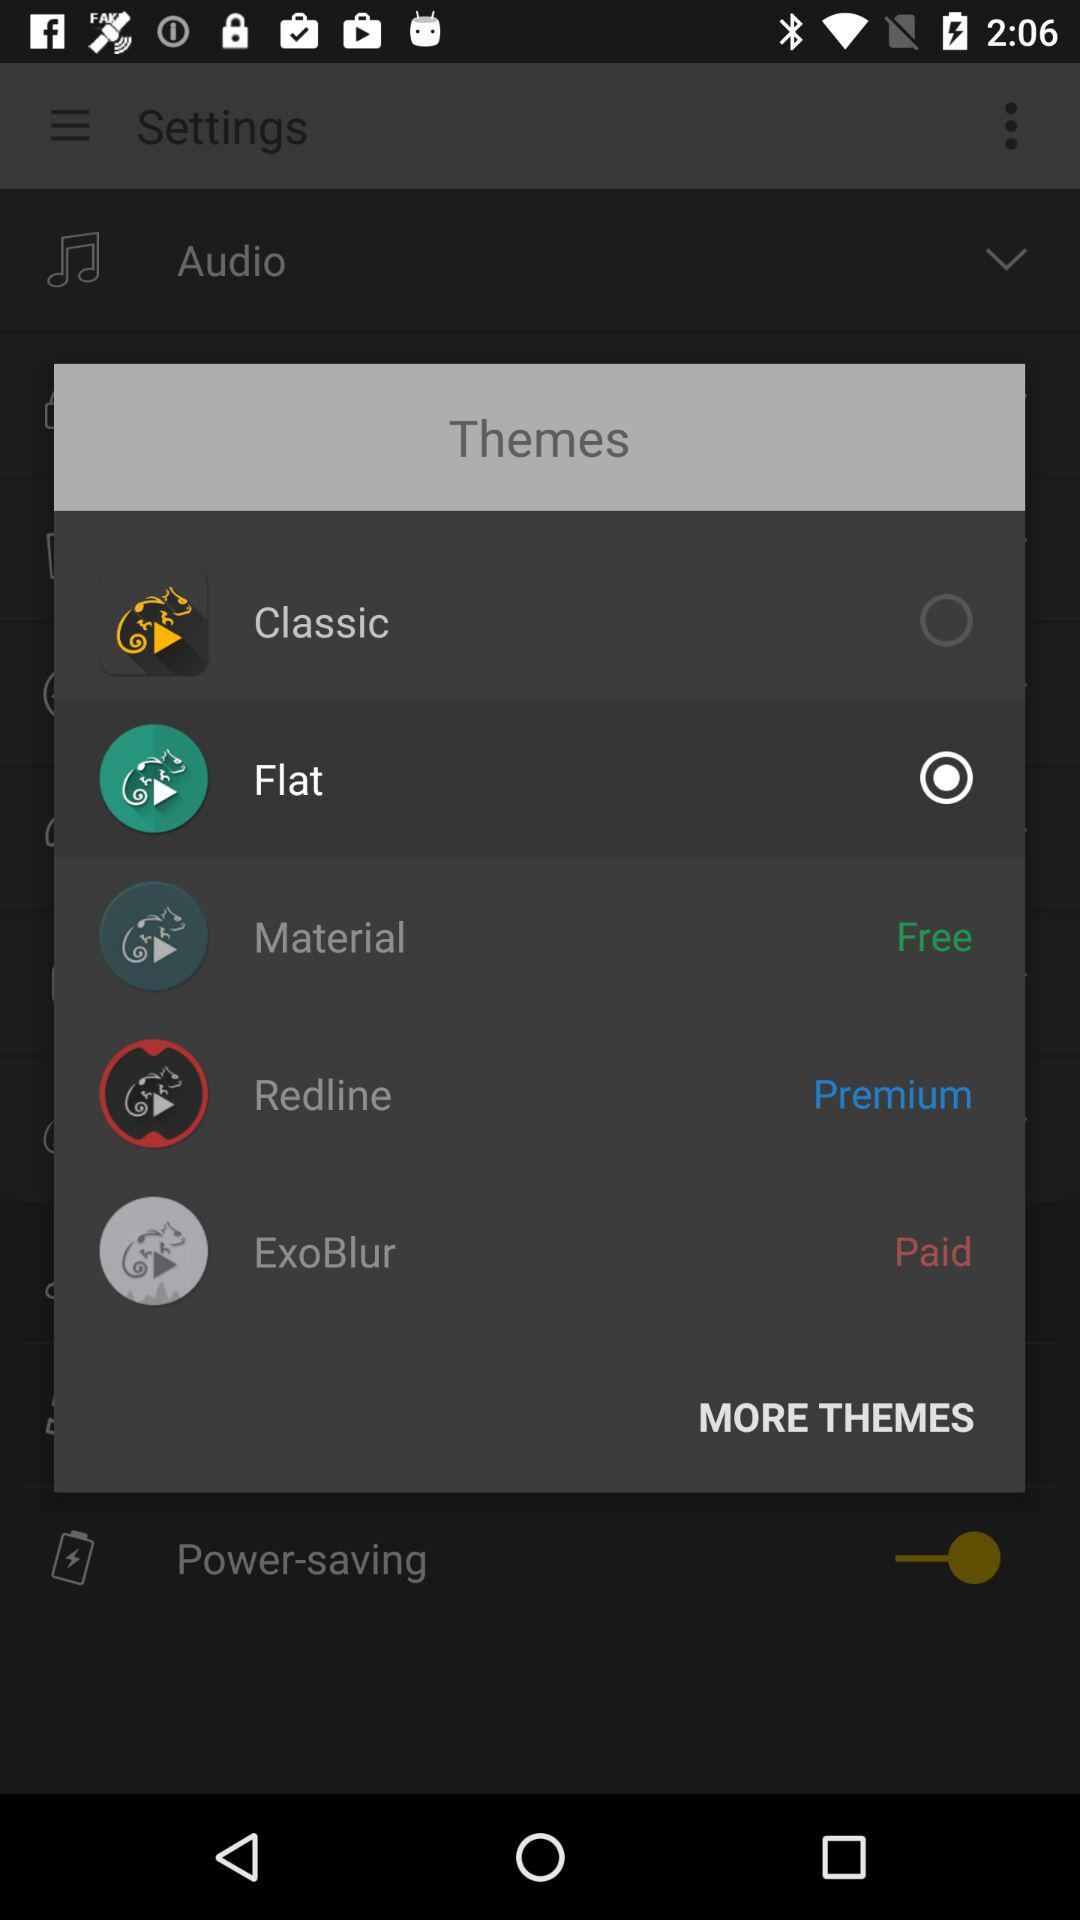Is "ExoBlur" free or paid? The "ExoBlur" is paid. 